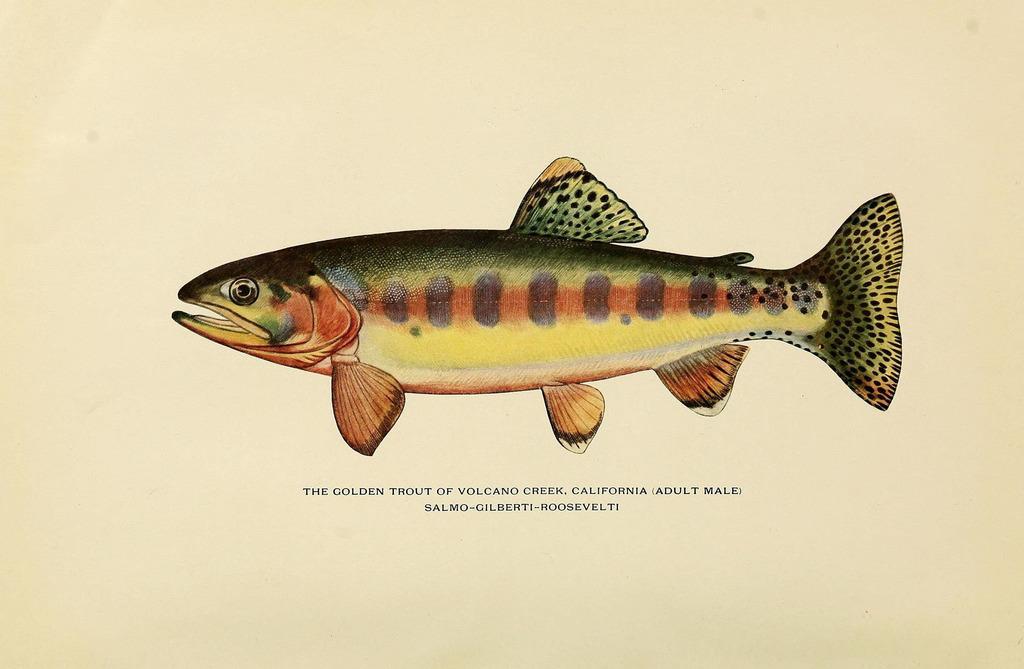Can you describe this image briefly? This image consists of a poster. In which there is a fist. At the bottom, there is a text. 